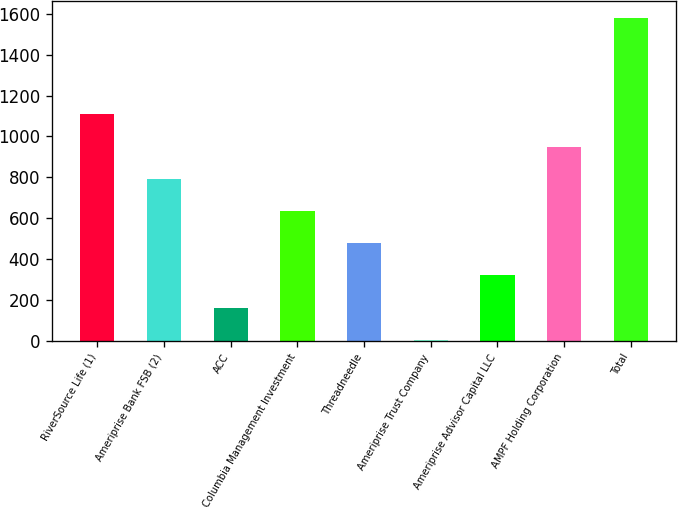Convert chart. <chart><loc_0><loc_0><loc_500><loc_500><bar_chart><fcel>RiverSource Life (1)<fcel>Ameriprise Bank FSB (2)<fcel>ACC<fcel>Columbia Management Investment<fcel>Threadneedle<fcel>Ameriprise Trust Company<fcel>Ameriprise Advisor Capital LLC<fcel>AMPF Holding Corporation<fcel>Total<nl><fcel>1108.6<fcel>793<fcel>161.8<fcel>635.2<fcel>477.4<fcel>4<fcel>319.6<fcel>950.8<fcel>1582<nl></chart> 